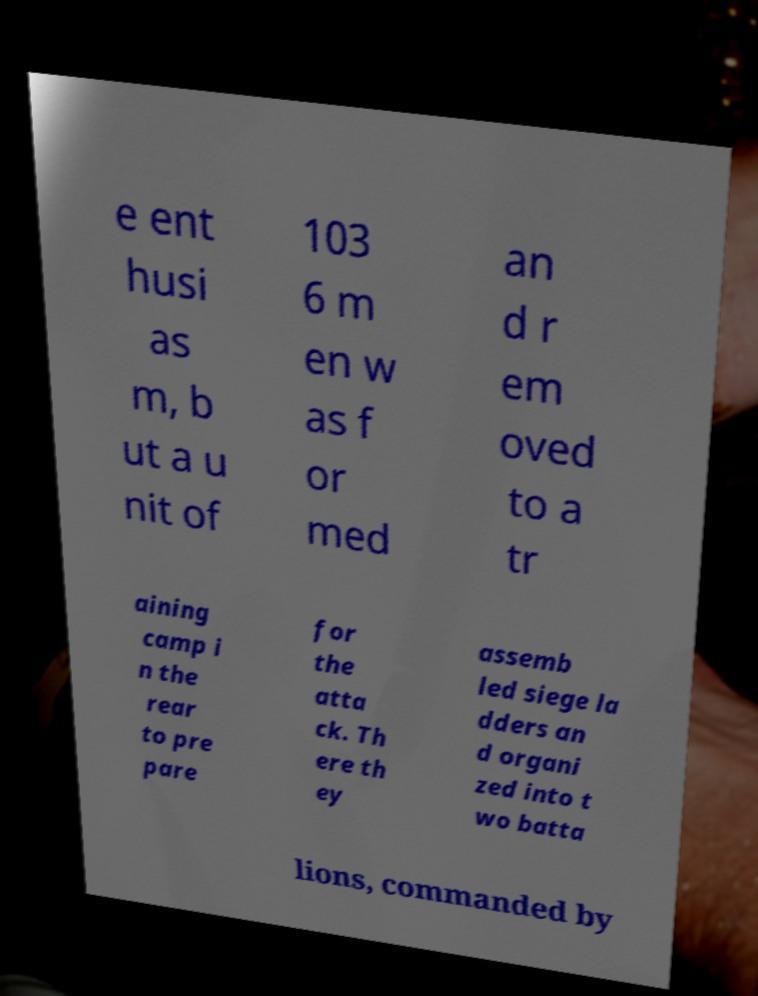What messages or text are displayed in this image? I need them in a readable, typed format. e ent husi as m, b ut a u nit of 103 6 m en w as f or med an d r em oved to a tr aining camp i n the rear to pre pare for the atta ck. Th ere th ey assemb led siege la dders an d organi zed into t wo batta lions, commanded by 